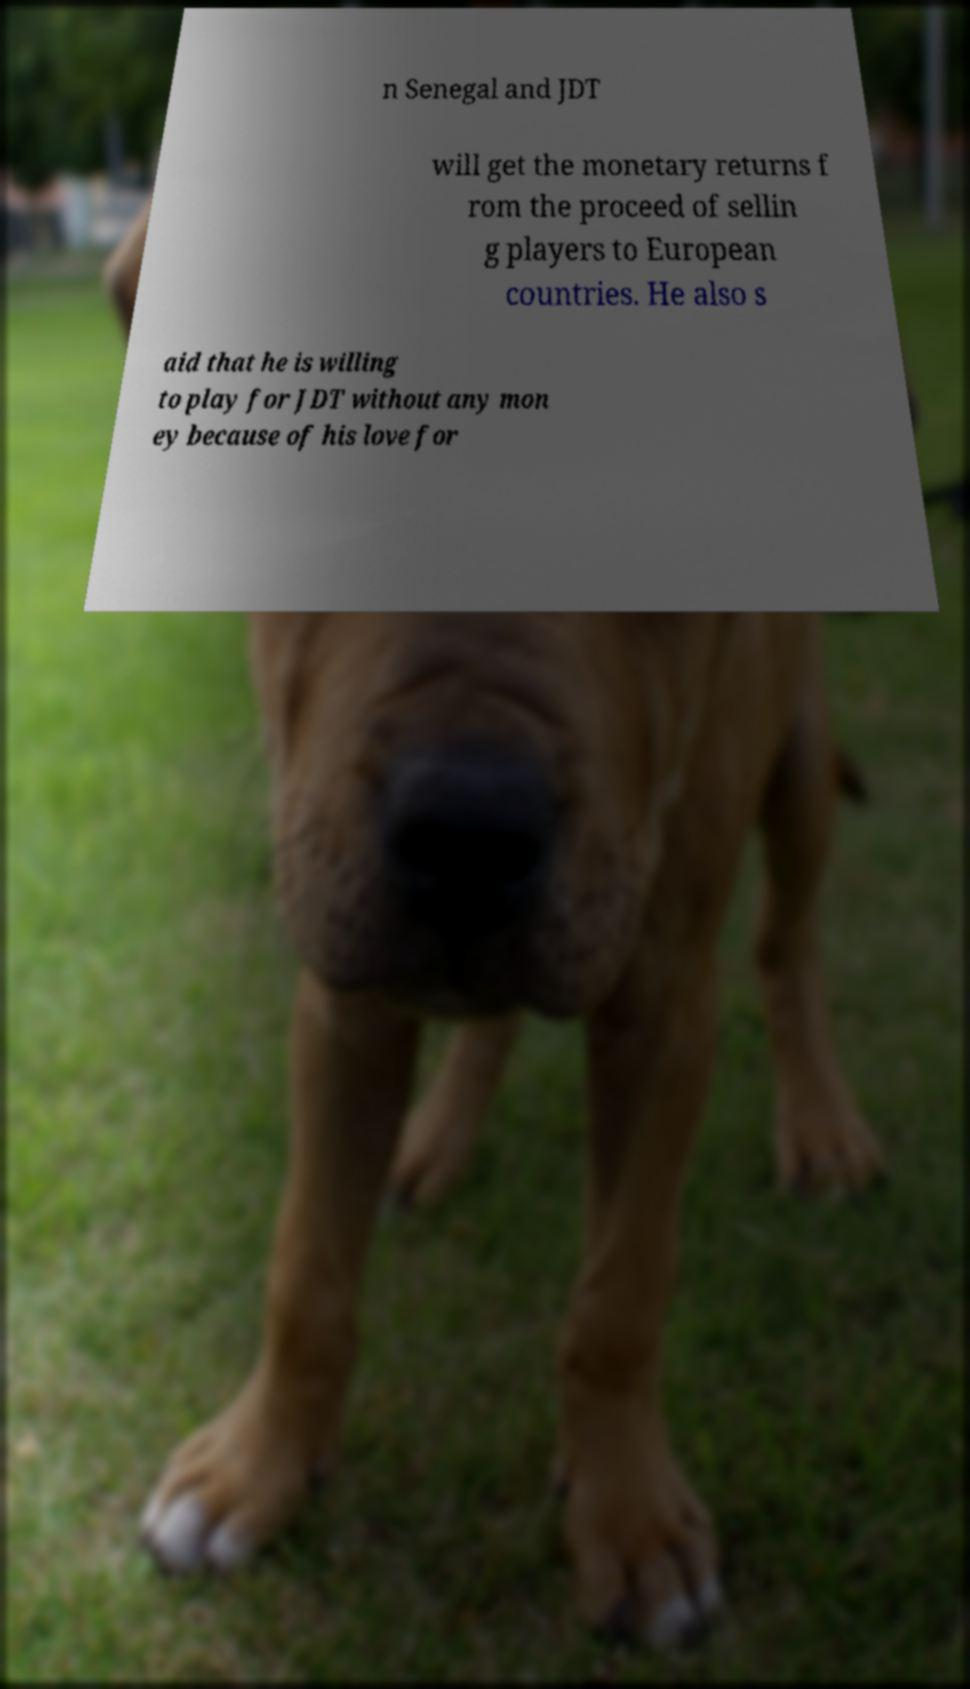Can you accurately transcribe the text from the provided image for me? n Senegal and JDT will get the monetary returns f rom the proceed of sellin g players to European countries. He also s aid that he is willing to play for JDT without any mon ey because of his love for 